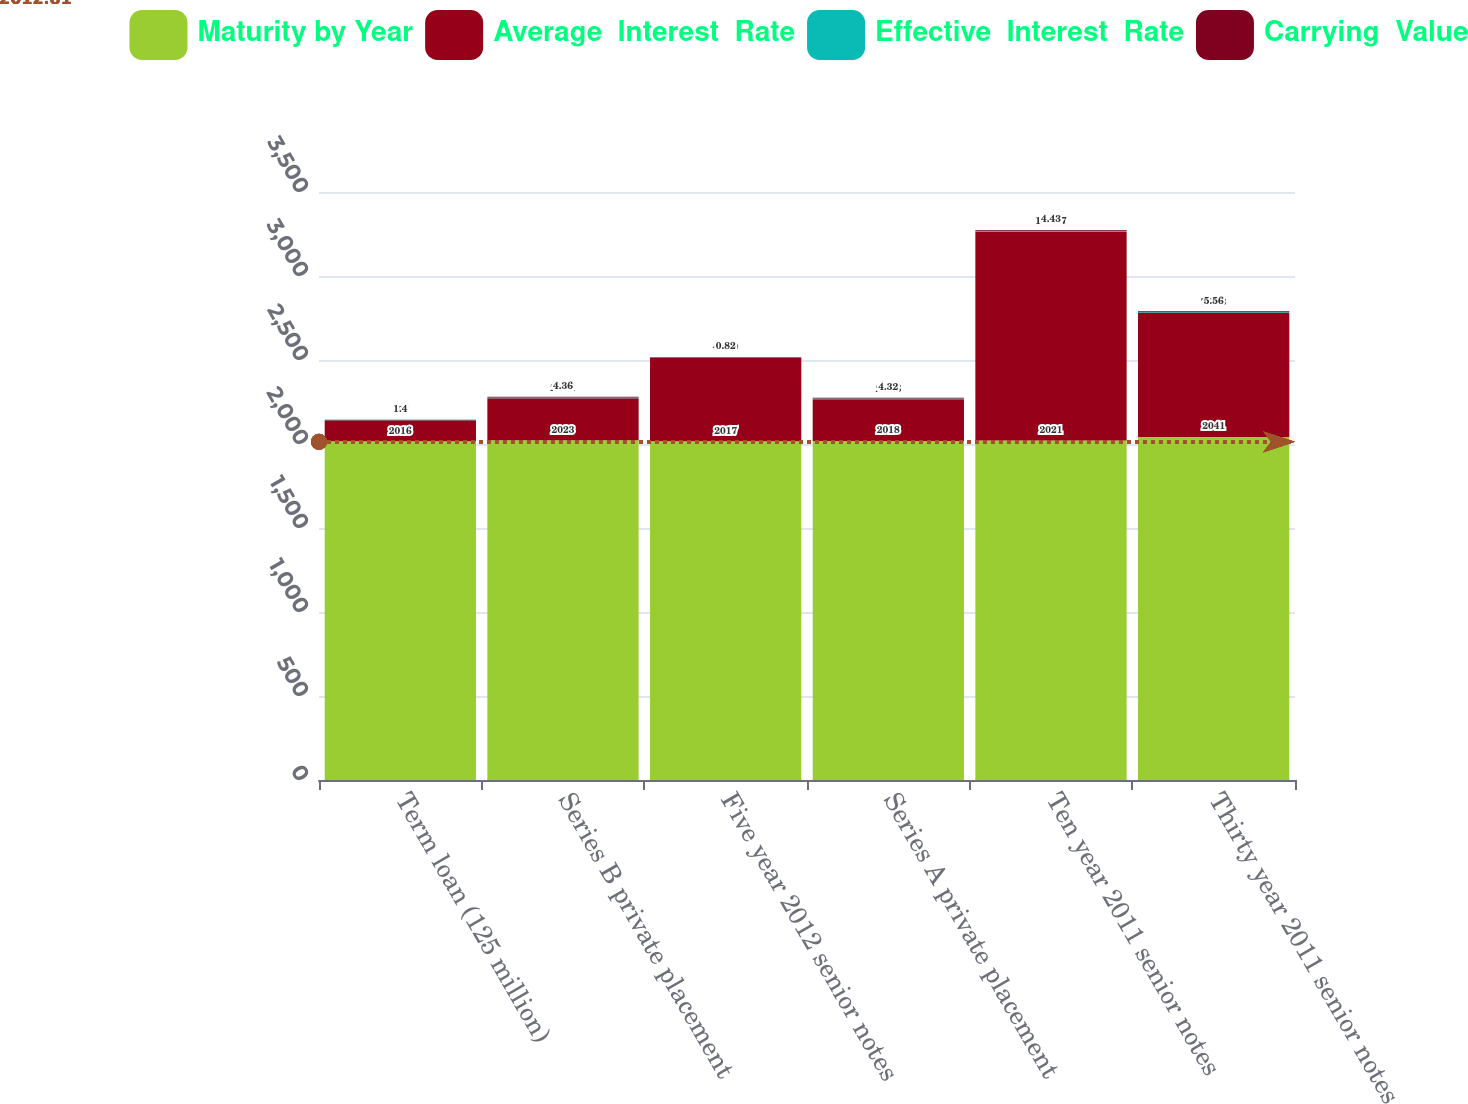<chart> <loc_0><loc_0><loc_500><loc_500><stacked_bar_chart><ecel><fcel>Term loan (125 million)<fcel>Series B private placement<fcel>Five year 2012 senior notes<fcel>Series A private placement<fcel>Ten year 2011 senior notes<fcel>Thirty year 2011 senior notes<nl><fcel>Maturity by Year<fcel>2016<fcel>2023<fcel>2017<fcel>2018<fcel>2021<fcel>2041<nl><fcel>Average  Interest  Rate<fcel>125<fcel>249.1<fcel>497.9<fcel>248.6<fcel>1243.7<fcel>738.3<nl><fcel>Effective  Interest  Rate<fcel>1.4<fcel>4.32<fcel>1.45<fcel>3.69<fcel>4.35<fcel>5.5<nl><fcel>Carrying  Value<fcel>1.4<fcel>4.36<fcel>0.82<fcel>4.32<fcel>4.43<fcel>5.56<nl></chart> 